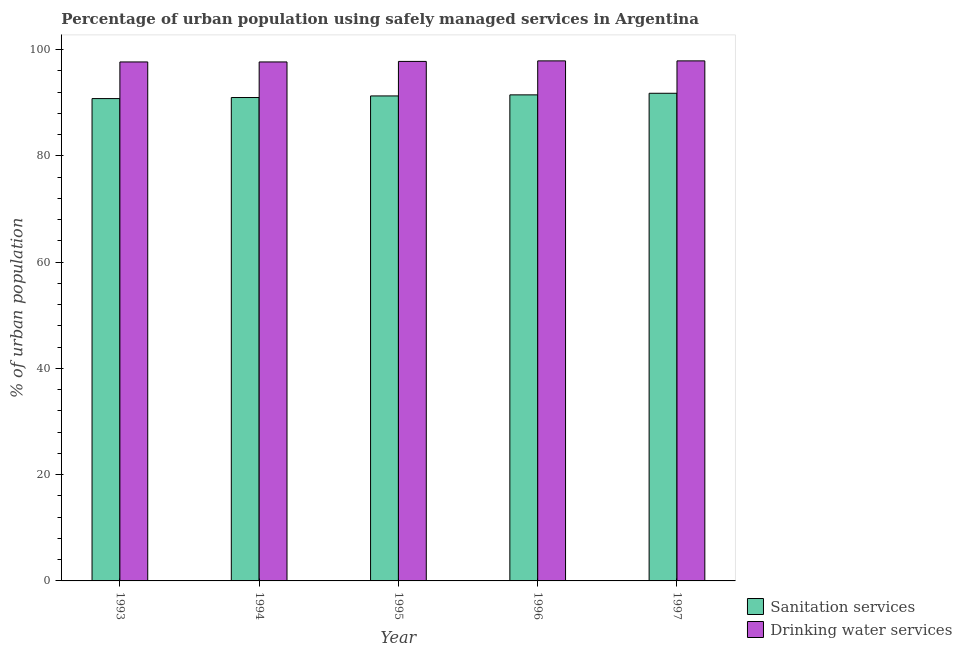How many different coloured bars are there?
Keep it short and to the point. 2. How many groups of bars are there?
Ensure brevity in your answer.  5. Are the number of bars on each tick of the X-axis equal?
Ensure brevity in your answer.  Yes. How many bars are there on the 5th tick from the right?
Provide a short and direct response. 2. What is the label of the 4th group of bars from the left?
Provide a succinct answer. 1996. In how many cases, is the number of bars for a given year not equal to the number of legend labels?
Your answer should be very brief. 0. What is the percentage of urban population who used drinking water services in 1993?
Offer a terse response. 97.7. Across all years, what is the maximum percentage of urban population who used sanitation services?
Give a very brief answer. 91.8. Across all years, what is the minimum percentage of urban population who used sanitation services?
Give a very brief answer. 90.8. In which year was the percentage of urban population who used drinking water services maximum?
Offer a very short reply. 1996. What is the total percentage of urban population who used sanitation services in the graph?
Provide a succinct answer. 456.4. What is the difference between the percentage of urban population who used drinking water services in 1996 and that in 1997?
Your answer should be compact. 0. What is the difference between the percentage of urban population who used drinking water services in 1996 and the percentage of urban population who used sanitation services in 1993?
Your response must be concise. 0.2. What is the average percentage of urban population who used drinking water services per year?
Offer a very short reply. 97.8. In how many years, is the percentage of urban population who used sanitation services greater than 36 %?
Ensure brevity in your answer.  5. What is the ratio of the percentage of urban population who used sanitation services in 1995 to that in 1996?
Offer a terse response. 1. Is the difference between the percentage of urban population who used sanitation services in 1993 and 1996 greater than the difference between the percentage of urban population who used drinking water services in 1993 and 1996?
Offer a terse response. No. Is the sum of the percentage of urban population who used drinking water services in 1994 and 1997 greater than the maximum percentage of urban population who used sanitation services across all years?
Keep it short and to the point. Yes. What does the 2nd bar from the left in 1997 represents?
Ensure brevity in your answer.  Drinking water services. What does the 1st bar from the right in 1993 represents?
Provide a short and direct response. Drinking water services. How many bars are there?
Ensure brevity in your answer.  10. Are all the bars in the graph horizontal?
Provide a short and direct response. No. What is the difference between two consecutive major ticks on the Y-axis?
Your answer should be compact. 20. Are the values on the major ticks of Y-axis written in scientific E-notation?
Ensure brevity in your answer.  No. Does the graph contain any zero values?
Make the answer very short. No. Does the graph contain grids?
Offer a very short reply. No. Where does the legend appear in the graph?
Ensure brevity in your answer.  Bottom right. What is the title of the graph?
Your answer should be compact. Percentage of urban population using safely managed services in Argentina. Does "Exports of goods" appear as one of the legend labels in the graph?
Give a very brief answer. No. What is the label or title of the Y-axis?
Offer a terse response. % of urban population. What is the % of urban population of Sanitation services in 1993?
Keep it short and to the point. 90.8. What is the % of urban population in Drinking water services in 1993?
Offer a terse response. 97.7. What is the % of urban population of Sanitation services in 1994?
Your answer should be very brief. 91. What is the % of urban population in Drinking water services in 1994?
Make the answer very short. 97.7. What is the % of urban population in Sanitation services in 1995?
Provide a short and direct response. 91.3. What is the % of urban population of Drinking water services in 1995?
Keep it short and to the point. 97.8. What is the % of urban population in Sanitation services in 1996?
Provide a succinct answer. 91.5. What is the % of urban population in Drinking water services in 1996?
Keep it short and to the point. 97.9. What is the % of urban population of Sanitation services in 1997?
Provide a succinct answer. 91.8. What is the % of urban population of Drinking water services in 1997?
Your answer should be compact. 97.9. Across all years, what is the maximum % of urban population in Sanitation services?
Make the answer very short. 91.8. Across all years, what is the maximum % of urban population of Drinking water services?
Make the answer very short. 97.9. Across all years, what is the minimum % of urban population of Sanitation services?
Your answer should be compact. 90.8. Across all years, what is the minimum % of urban population of Drinking water services?
Provide a succinct answer. 97.7. What is the total % of urban population of Sanitation services in the graph?
Your response must be concise. 456.4. What is the total % of urban population in Drinking water services in the graph?
Make the answer very short. 489. What is the difference between the % of urban population in Sanitation services in 1993 and that in 1994?
Make the answer very short. -0.2. What is the difference between the % of urban population of Drinking water services in 1993 and that in 1994?
Your answer should be very brief. 0. What is the difference between the % of urban population of Sanitation services in 1993 and that in 1996?
Your answer should be compact. -0.7. What is the difference between the % of urban population of Drinking water services in 1993 and that in 1996?
Keep it short and to the point. -0.2. What is the difference between the % of urban population of Sanitation services in 1993 and that in 1997?
Your answer should be very brief. -1. What is the difference between the % of urban population in Drinking water services in 1994 and that in 1995?
Keep it short and to the point. -0.1. What is the difference between the % of urban population of Drinking water services in 1994 and that in 1996?
Give a very brief answer. -0.2. What is the difference between the % of urban population in Sanitation services in 1994 and that in 1997?
Ensure brevity in your answer.  -0.8. What is the difference between the % of urban population of Drinking water services in 1994 and that in 1997?
Offer a terse response. -0.2. What is the difference between the % of urban population in Sanitation services in 1995 and that in 1996?
Make the answer very short. -0.2. What is the difference between the % of urban population of Drinking water services in 1995 and that in 1996?
Offer a terse response. -0.1. What is the difference between the % of urban population of Sanitation services in 1995 and that in 1997?
Provide a short and direct response. -0.5. What is the difference between the % of urban population in Drinking water services in 1995 and that in 1997?
Make the answer very short. -0.1. What is the difference between the % of urban population in Sanitation services in 1996 and that in 1997?
Keep it short and to the point. -0.3. What is the difference between the % of urban population in Sanitation services in 1994 and the % of urban population in Drinking water services in 1995?
Ensure brevity in your answer.  -6.8. What is the difference between the % of urban population of Sanitation services in 1994 and the % of urban population of Drinking water services in 1996?
Offer a terse response. -6.9. What is the difference between the % of urban population in Sanitation services in 1995 and the % of urban population in Drinking water services in 1996?
Make the answer very short. -6.6. What is the difference between the % of urban population in Sanitation services in 1995 and the % of urban population in Drinking water services in 1997?
Provide a succinct answer. -6.6. What is the average % of urban population in Sanitation services per year?
Your answer should be compact. 91.28. What is the average % of urban population of Drinking water services per year?
Offer a very short reply. 97.8. In the year 1993, what is the difference between the % of urban population of Sanitation services and % of urban population of Drinking water services?
Your response must be concise. -6.9. In the year 1995, what is the difference between the % of urban population in Sanitation services and % of urban population in Drinking water services?
Provide a succinct answer. -6.5. What is the ratio of the % of urban population in Sanitation services in 1993 to that in 1995?
Offer a terse response. 0.99. What is the ratio of the % of urban population of Drinking water services in 1993 to that in 1995?
Your response must be concise. 1. What is the ratio of the % of urban population of Sanitation services in 1993 to that in 1996?
Offer a terse response. 0.99. What is the ratio of the % of urban population in Drinking water services in 1993 to that in 1997?
Provide a short and direct response. 1. What is the ratio of the % of urban population of Sanitation services in 1994 to that in 1995?
Provide a succinct answer. 1. What is the ratio of the % of urban population in Drinking water services in 1994 to that in 1995?
Keep it short and to the point. 1. What is the ratio of the % of urban population in Drinking water services in 1994 to that in 1996?
Make the answer very short. 1. What is the ratio of the % of urban population in Sanitation services in 1994 to that in 1997?
Keep it short and to the point. 0.99. What is the ratio of the % of urban population of Drinking water services in 1994 to that in 1997?
Your response must be concise. 1. What is the ratio of the % of urban population of Sanitation services in 1995 to that in 1997?
Your response must be concise. 0.99. What is the ratio of the % of urban population of Drinking water services in 1995 to that in 1997?
Your response must be concise. 1. What is the difference between the highest and the second highest % of urban population in Sanitation services?
Provide a short and direct response. 0.3. What is the difference between the highest and the second highest % of urban population in Drinking water services?
Offer a terse response. 0. What is the difference between the highest and the lowest % of urban population of Sanitation services?
Provide a short and direct response. 1. What is the difference between the highest and the lowest % of urban population of Drinking water services?
Offer a terse response. 0.2. 